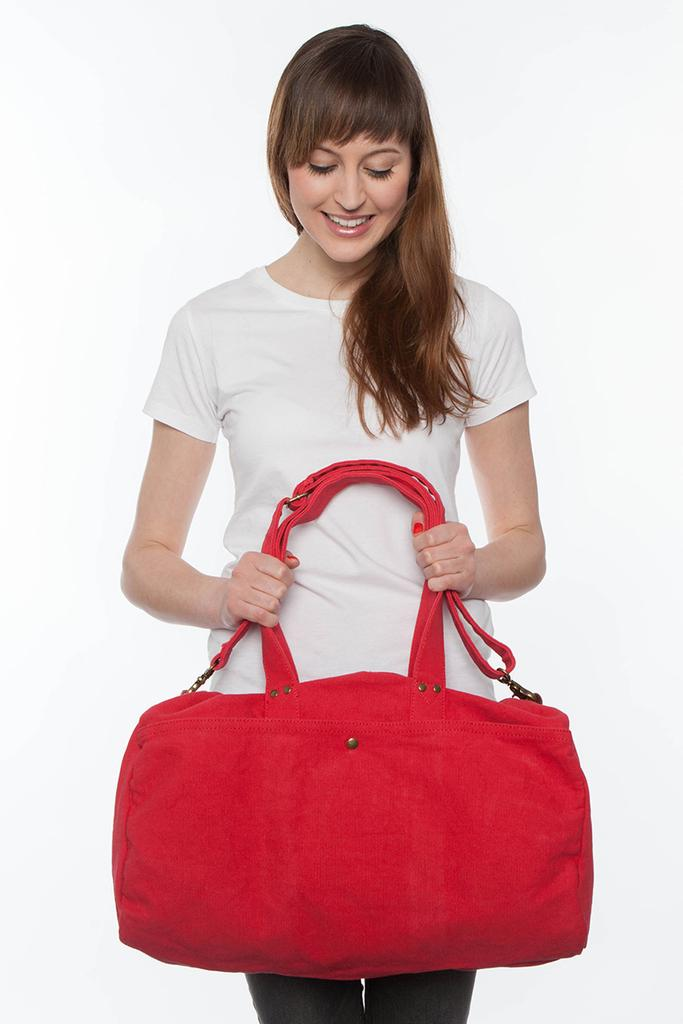Who is the main subject in the picture? There is a woman in the picture. What is the woman wearing? The woman is wearing a white T-shirt. What is the woman holding in her hands? The woman is holding a red color bag in her hands. Are there any bears visible in the picture? No, there are no bears present in the image. What type of metal can be seen in the picture? There is no metal, such as zinc, visible in the picture. 